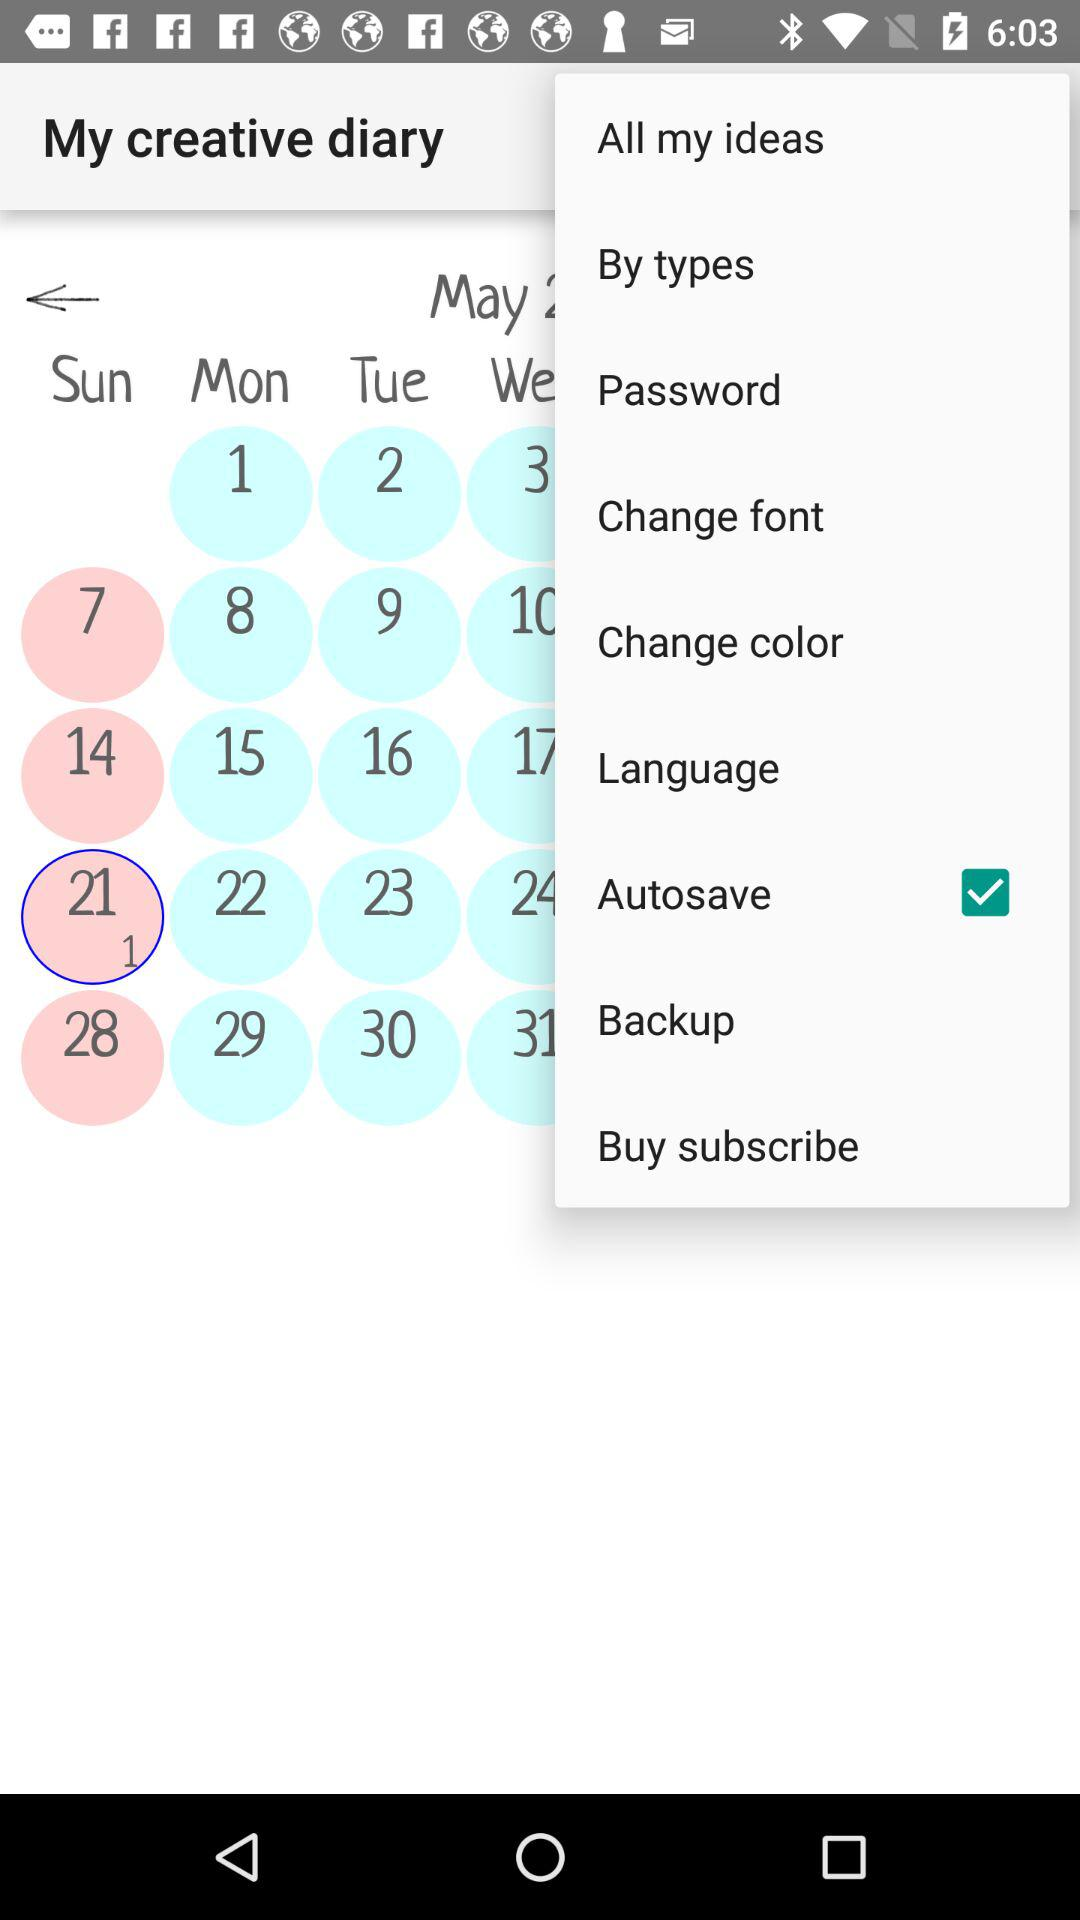Which date is selected? The selected date is Sunday, May 21. 